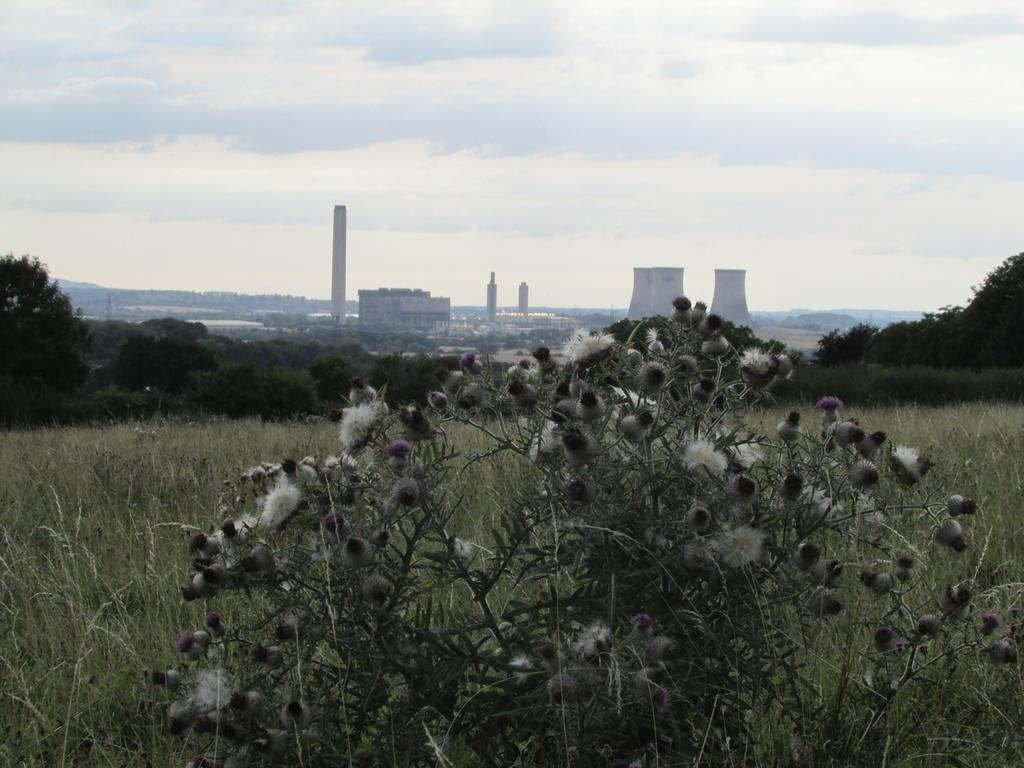What is located in the foreground of the image? There is a plant in the foreground of the image. What can be seen in the background of the image? There are plants, trees, buildings, and towers in the background of the image. What is visible at the top of the image? The sky is visible at the top of the image. Where is the friend sitting at the table in the image? There is no friend or table present in the image. 